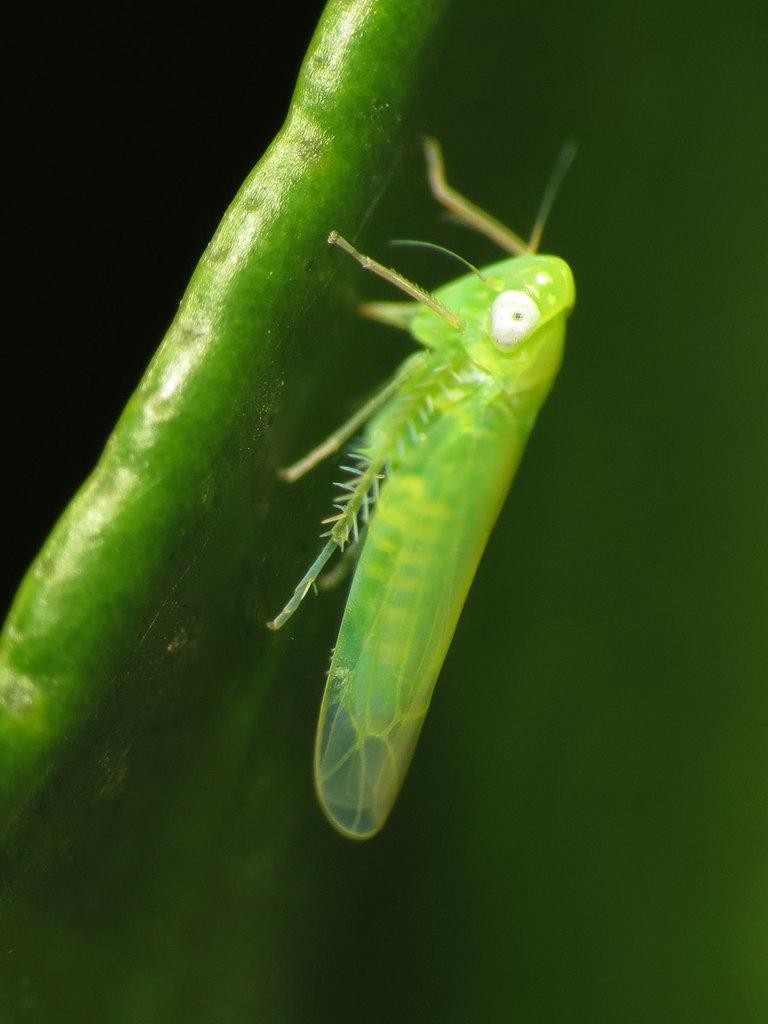What is the main subject of the image? The main subject of the image is a grasshopper. Where is the grasshopper located in the image? The grasshopper is on a leaf. What type of airplane is being fueled in the image? There is no airplane present in the image, as it features a grasshopper on a leaf. What type of support is the grasshopper using to stay on the leaf? The grasshopper's legs are likely providing the support to stay on the leaf, as insects typically use their legs for support and movement. 